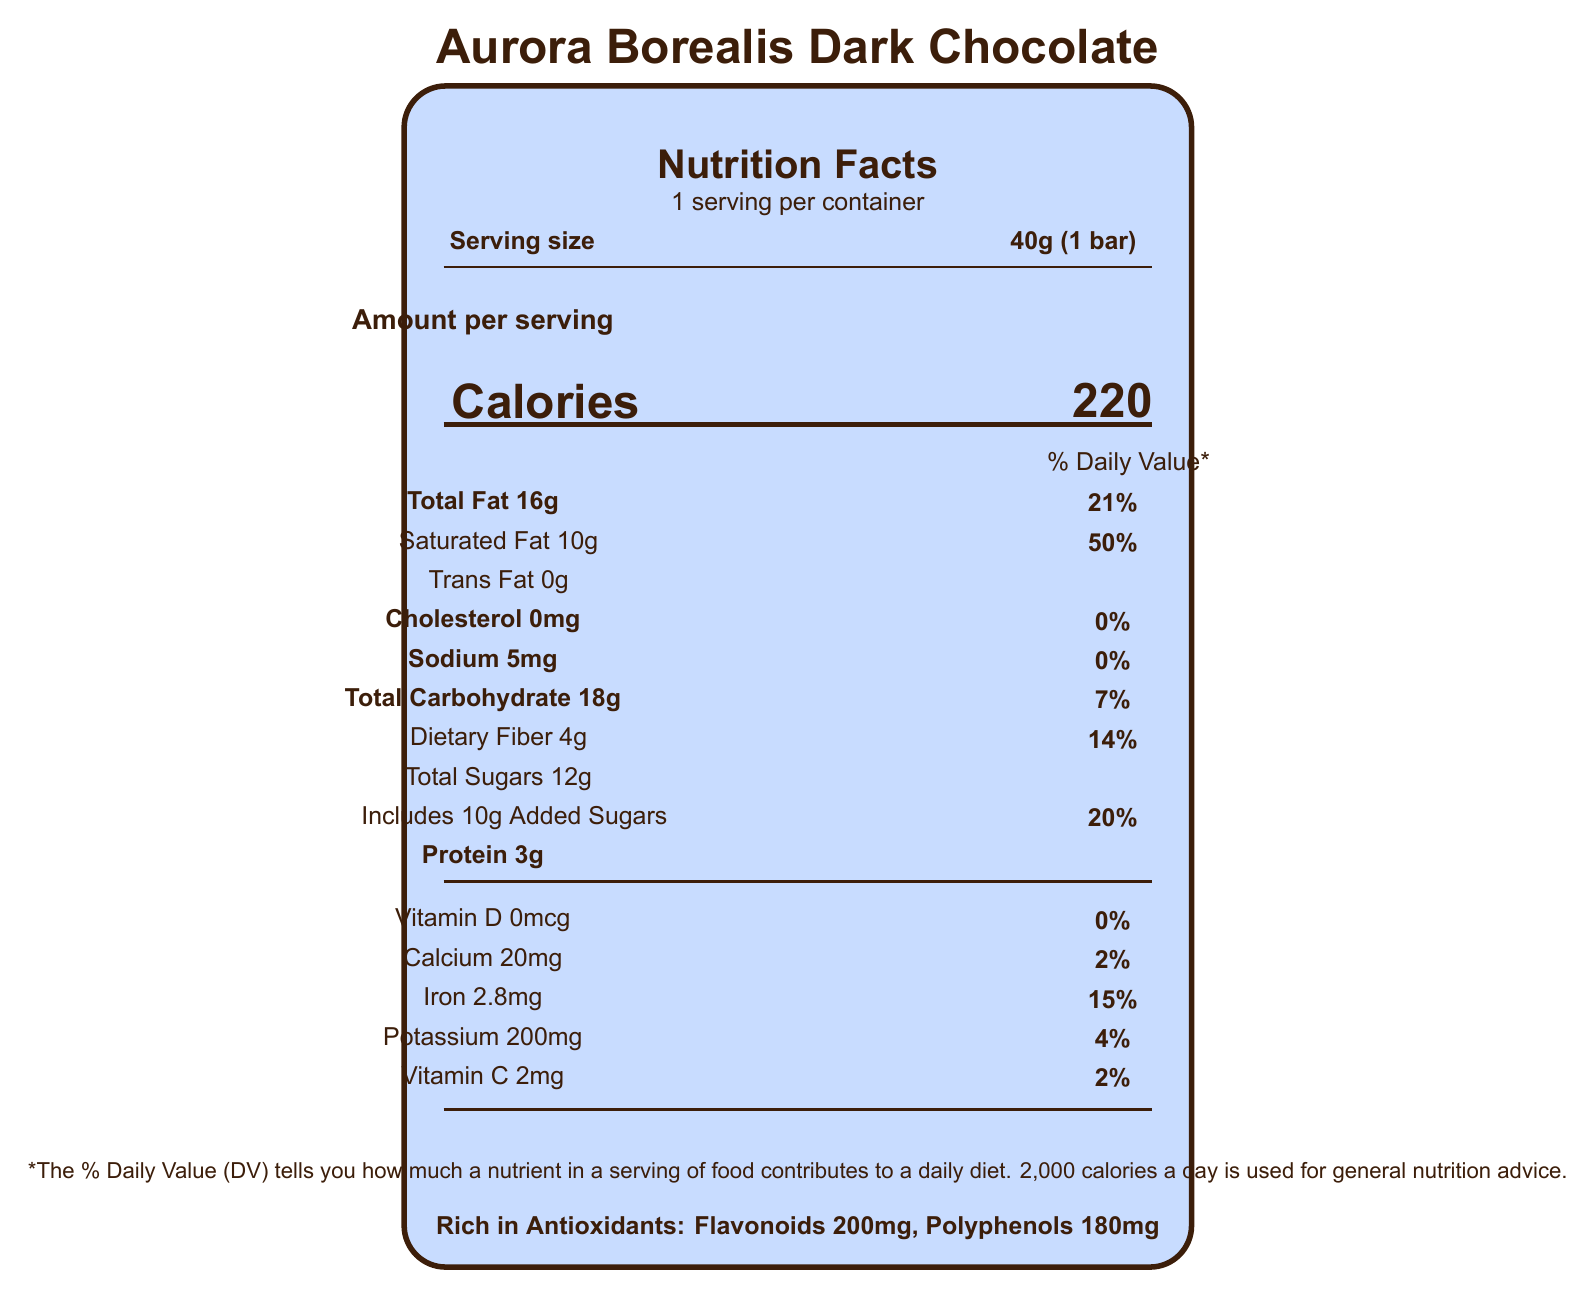what is the serving size of the Aurora Borealis Dark Chocolate? The serving size is clearly listed as "40g (1 bar)" in the nutrition facts.
Answer: 40g (1 bar) how many calories are in one serving of the chocolate bar? The amount of calories per serving is stated as 220.
Answer: 220 how much total fat is in one serving? The document lists the total fat content per serving as 16g.
Answer: 16g what percentage of the daily value does the saturated fat represent? The daily value percentage for saturated fat is indicated as 50%.
Answer: 50% what is the amount of sodium in one serving? According to the label, one serving contains 5mg of sodium.
Answer: 5mg how much dietary fiber does the chocolate bar contain? The dietary fiber content per serving is listed as 4g.
Answer: 4g how many grams of added sugars are there? The document mentions that there are 10g of added sugars.
Answer: 10g what is the percentage of the daily value for iron? The daily value percentage for iron indicated on the label is 15%.
Answer: 15% what is the manufacturer's name and location? The manufacturer is listed as Lumi Suklaa Oy, located in Helsinki, Finland.
Answer: Lumi Suklaa Oy, Helsinki, Finland what should be the storage conditions for this chocolate bar? A. Store in a fridge B. Store at room temperature C. Store in a cool, dry place (16-18°C) D. Freeze The storage instructions specify "Store in a cool, dry place (16-18°C)."
Answer: C which of the following nutrients is not present in the chocolate bar? I. Vitamin D II. Trans Fat III. Protein The label shows that there is 0mcg of Vitamin D and 0g of Trans Fat, so both these nutrients are not present.
Answer: I, II is the chocolate bar rich in antioxidants? The label specifically mentions that the chocolate is rich in antioxidants, including flavonoids (200mg) and polyphenols (180mg).
Answer: Yes does the document provide information on artificial preservatives? The document mentions that there are no artificial flavors or preservatives.
Answer: No summarize the nutritional profile and special features of the Aurora Borealis Dark Chocolate. The summary encompasses all key nutritional values and special features such as antioxidant content, ingredients, and other product attributes mentioned in the document.
Answer: The Aurora Borealis Dark Chocolate has a serving size of 40g, providing 220 calories per serving. It contains 16g of total fat (21% DV), 10g of saturated fat (50% DV), 0g of trans fat, 5mg of sodium (0% DV), 18g of total carbohydrates (7% DV) including 4g of dietary fiber (14% DV) and 12g of total sugars with 10g of added sugars (20% DV). It also has 3g of protein, 0mcg of Vitamin D (0% DV), 20mg of calcium (2% DV), 2.8mg of iron (15% DV), 200mg of potassium (4% DV), and 2mg of Vitamin C (2% DV). The chocolate is rich in antioxidants: 200mg of flavonoids and 180mg of polyphenols. It is made from organic ingredients, including dark chocolate, Arctic berries, and has no artificial flavors or preservatives. The product is manufactured by Lumi Suklaa Oy in Helsinki, Finland, and is packaged in eco-friendly wrapping. what is the source of antioxidants in the chocolate bar? The label mentions the presence of antioxidants such as flavonoids and polyphenols but does not specify their exact sources in the visual information provided.
Answer: Not enough information 